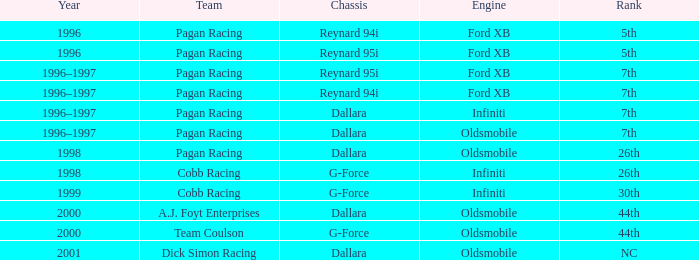Which engine finished 7th with the reynard 95i chassis? Ford XB. 